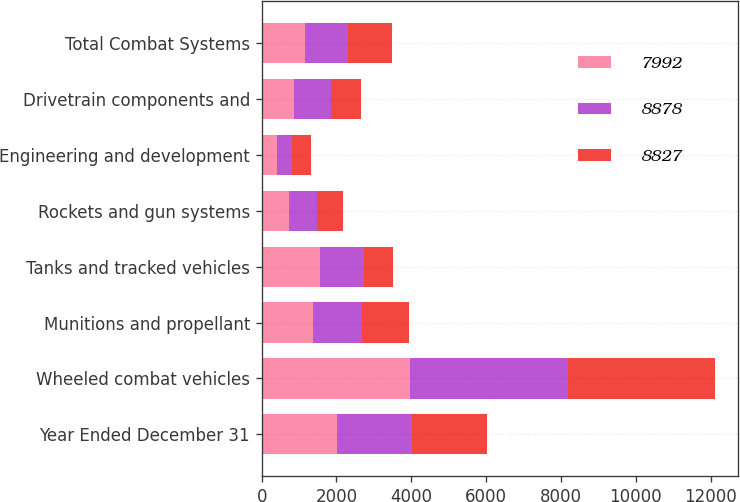Convert chart. <chart><loc_0><loc_0><loc_500><loc_500><stacked_bar_chart><ecel><fcel>Year Ended December 31<fcel>Wheeled combat vehicles<fcel>Munitions and propellant<fcel>Tanks and tracked vehicles<fcel>Rockets and gun systems<fcel>Engineering and development<fcel>Drivetrain components and<fcel>Total Combat Systems<nl><fcel>7992<fcel>2010<fcel>3961<fcel>1359<fcel>1567<fcel>728<fcel>408<fcel>855<fcel>1159<nl><fcel>8878<fcel>2011<fcel>4220<fcel>1314<fcel>1159<fcel>740<fcel>397<fcel>997<fcel>1159<nl><fcel>8827<fcel>2012<fcel>3930<fcel>1252<fcel>792<fcel>698<fcel>516<fcel>804<fcel>1159<nl></chart> 